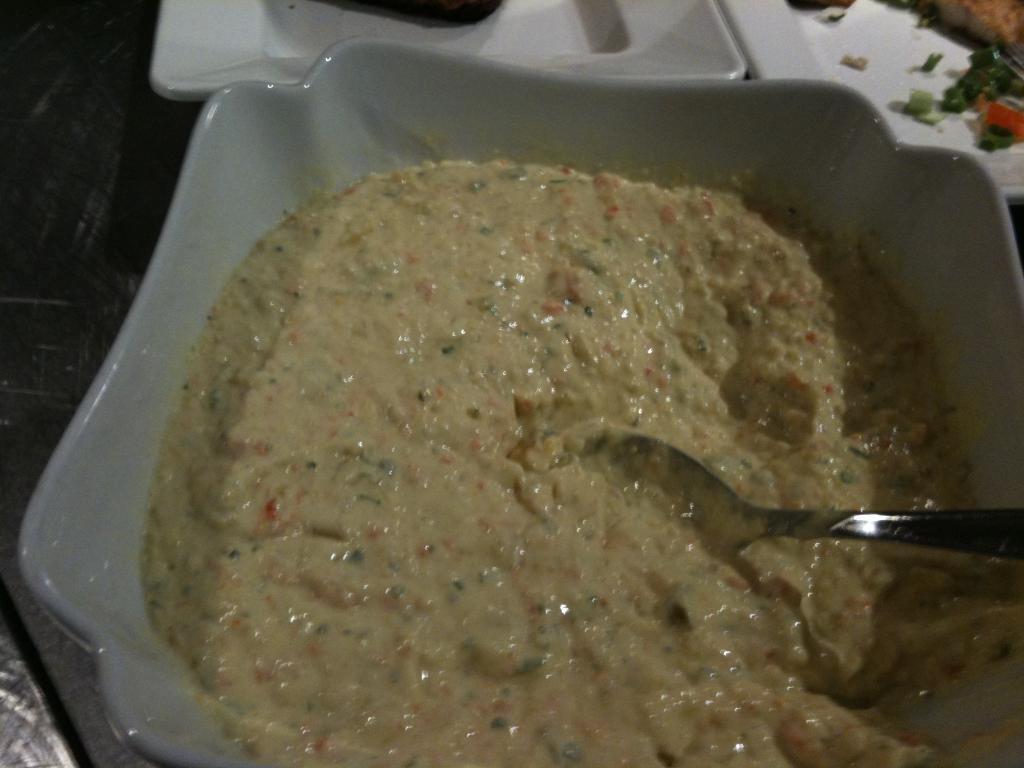In one or two sentences, can you explain what this image depicts? In this image in the center there is one plate and in the plate there is food and one spoon, and in the background there are plates. And in the plates there is food, at the bottom it looks like a table. 